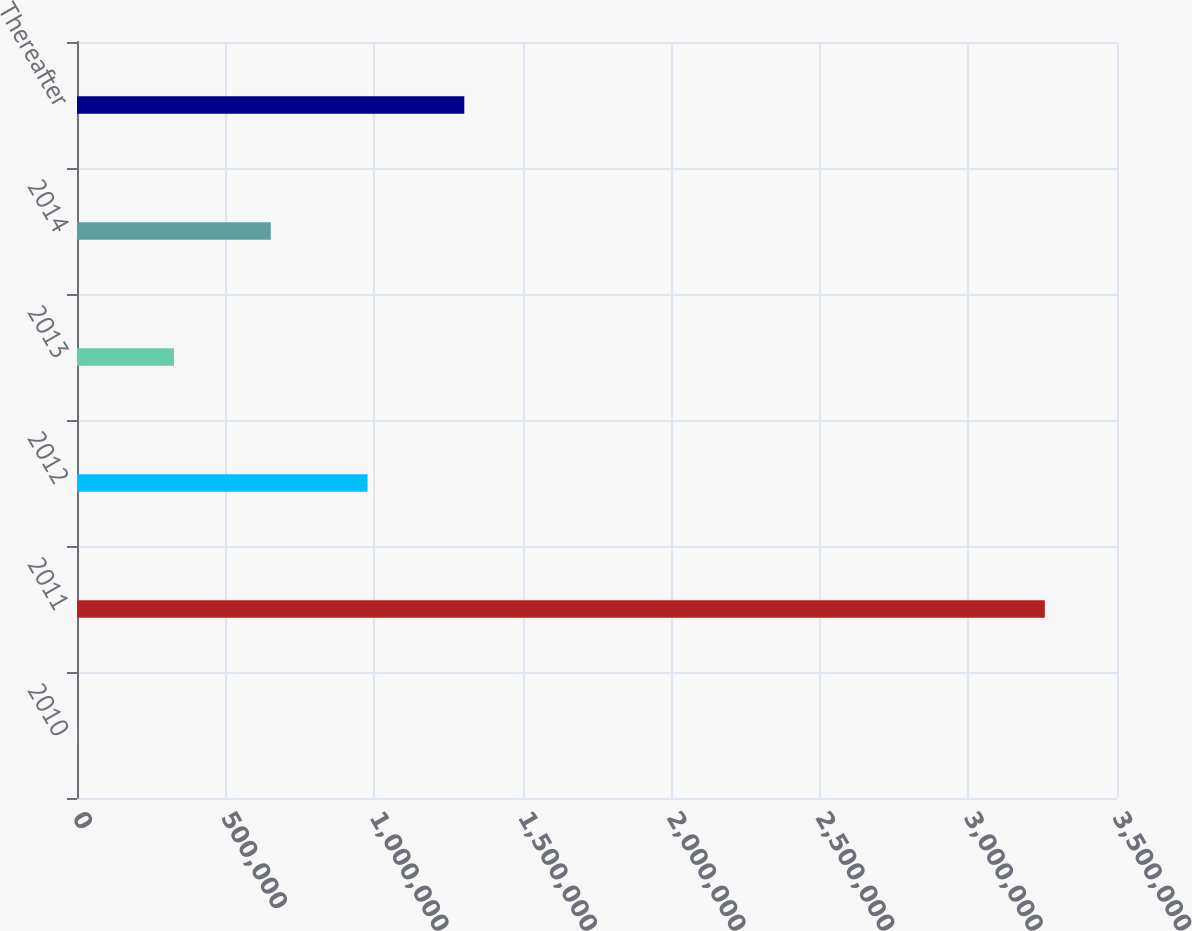<chart> <loc_0><loc_0><loc_500><loc_500><bar_chart><fcel>2010<fcel>2011<fcel>2012<fcel>2013<fcel>2014<fcel>Thereafter<nl><fcel>868<fcel>3.2572e+06<fcel>977768<fcel>326501<fcel>652135<fcel>1.3034e+06<nl></chart> 